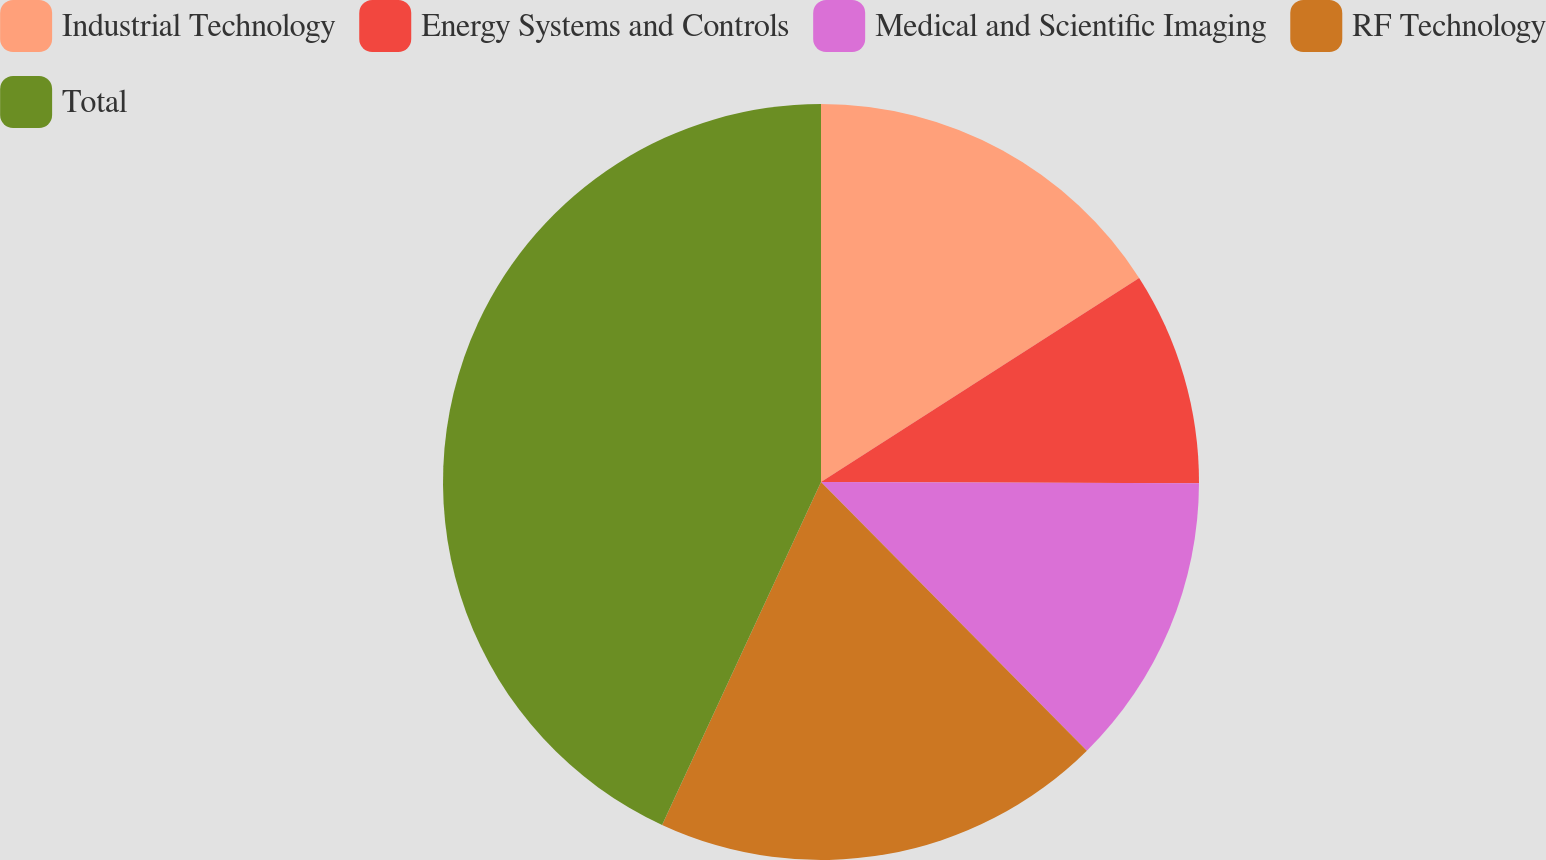Convert chart to OTSL. <chart><loc_0><loc_0><loc_500><loc_500><pie_chart><fcel>Industrial Technology<fcel>Energy Systems and Controls<fcel>Medical and Scientific Imaging<fcel>RF Technology<fcel>Total<nl><fcel>15.92%<fcel>9.13%<fcel>12.53%<fcel>19.32%<fcel>43.09%<nl></chart> 